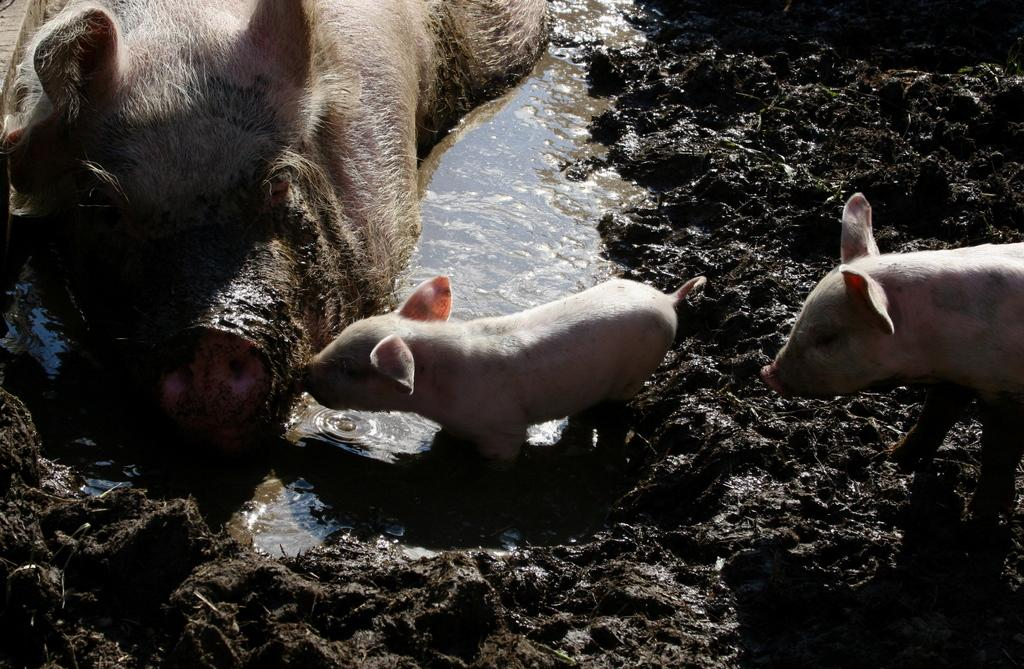What animals are present in the image? There are pigs in the image. What is the primary element visible in the image? Water is visible in the image. What type of terrain can be seen in the image? There is mud in the image. What type of bead is being used to expand the pigs' living space in the image? There is no bead or expansion of the pigs' living space present in the image. 